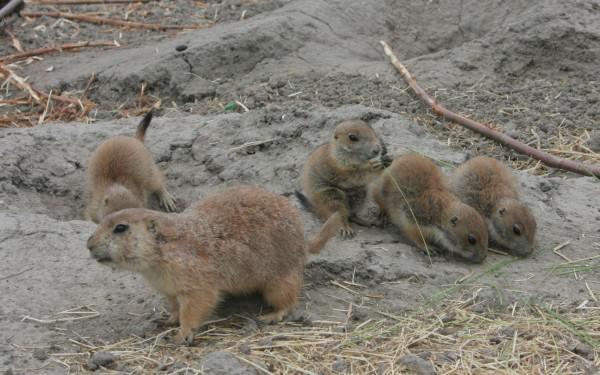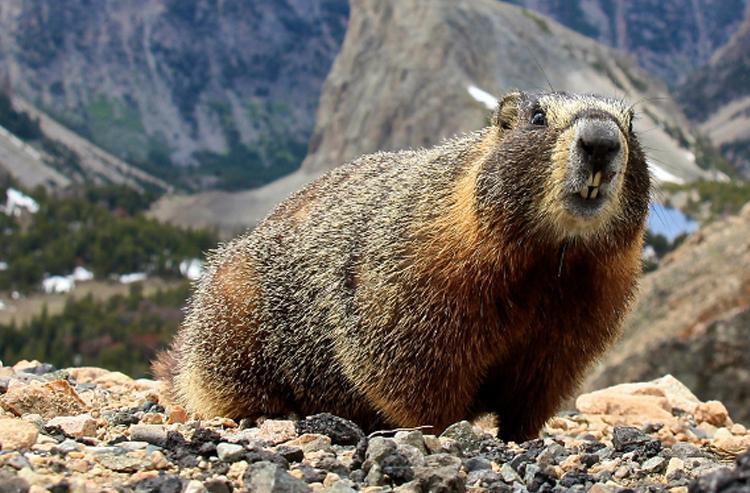The first image is the image on the left, the second image is the image on the right. Assess this claim about the two images: "There are two animals total.". Correct or not? Answer yes or no. No. The first image is the image on the left, the second image is the image on the right. For the images shown, is this caption "Right image shows a non-upright marmot with lifted head facing rightward." true? Answer yes or no. Yes. 